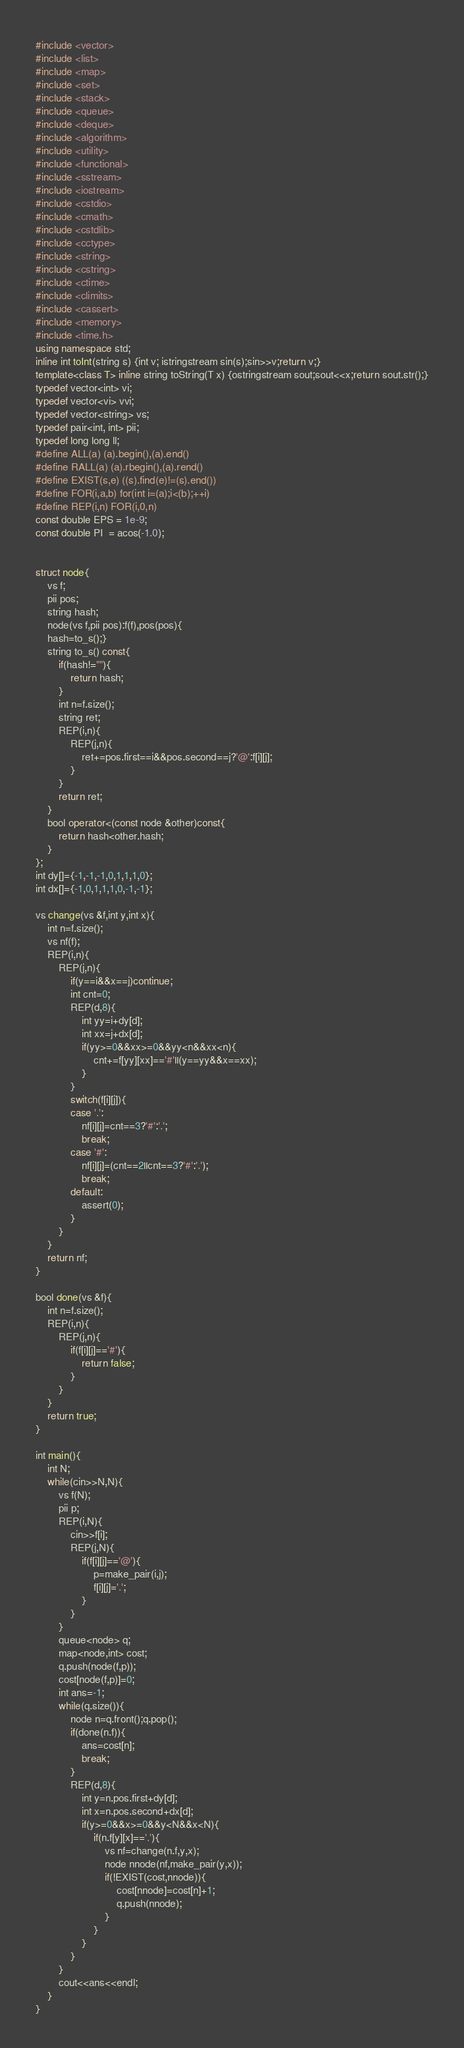Convert code to text. <code><loc_0><loc_0><loc_500><loc_500><_C++_>#include <vector>
#include <list>
#include <map>
#include <set>
#include <stack>
#include <queue>
#include <deque>
#include <algorithm>
#include <utility>
#include <functional>
#include <sstream>
#include <iostream>
#include <cstdio>
#include <cmath>
#include <cstdlib>
#include <cctype>
#include <string>
#include <cstring>
#include <ctime>
#include <climits>
#include <cassert>
#include <memory>
#include <time.h>
using namespace std;
inline int toInt(string s) {int v; istringstream sin(s);sin>>v;return v;}
template<class T> inline string toString(T x) {ostringstream sout;sout<<x;return sout.str();}
typedef vector<int> vi;
typedef vector<vi> vvi;
typedef vector<string> vs;
typedef pair<int, int> pii;
typedef long long ll;
#define ALL(a) (a).begin(),(a).end()
#define RALL(a) (a).rbegin(),(a).rend()
#define EXIST(s,e) ((s).find(e)!=(s).end())
#define FOR(i,a,b) for(int i=(a);i<(b);++i)
#define REP(i,n) FOR(i,0,n)
const double EPS = 1e-9;
const double PI  = acos(-1.0);


struct node{
	vs f;
	pii pos;
	string hash;
	node(vs f,pii pos):f(f),pos(pos){
	hash=to_s();}
	string to_s() const{
		if(hash!=""){
			return hash;
		}
		int n=f.size();
		string ret; 
		REP(i,n){
			REP(j,n){
				ret+=pos.first==i&&pos.second==j?'@':f[i][j];
			}
		}
		return ret;
	}
	bool operator<(const node &other)const{
		return hash<other.hash;
	}
};
int dy[]={-1,-1,-1,0,1,1,1,0};
int dx[]={-1,0,1,1,1,0,-1,-1};

vs change(vs &f,int y,int x){
	int n=f.size();
	vs nf(f);
	REP(i,n){
		REP(j,n){
			if(y==i&&x==j)continue;
			int cnt=0;
			REP(d,8){
				int yy=i+dy[d];
				int xx=j+dx[d];
				if(yy>=0&&xx>=0&&yy<n&&xx<n){
					cnt+=f[yy][xx]=='#'||(y==yy&&x==xx);
				}
			}
			switch(f[i][j]){
			case '.':
				nf[i][j]=cnt==3?'#':'.';
				break;
			case '#':
				nf[i][j]=(cnt==2||cnt==3?'#':'.');
				break;
			default:
				assert(0);
			}
		}
	}
	return nf;
}

bool done(vs &f){
	int n=f.size();
	REP(i,n){
		REP(j,n){
			if(f[i][j]=='#'){
				return false;
			}
		}
	}
	return true;
}

int main(){
	int N;
	while(cin>>N,N){
		vs f(N);
		pii p;
		REP(i,N){
			cin>>f[i];
			REP(j,N){
				if(f[i][j]=='@'){
					p=make_pair(i,j);
					f[i][j]='.';
				}
			}
		}
		queue<node> q;
		map<node,int> cost;
		q.push(node(f,p));
		cost[node(f,p)]=0;
		int ans=-1;
		while(q.size()){
			node n=q.front();q.pop();
			if(done(n.f)){
				ans=cost[n];
				break;
			}
			REP(d,8){
				int y=n.pos.first+dy[d];
				int x=n.pos.second+dx[d];
				if(y>=0&&x>=0&&y<N&&x<N){
					if(n.f[y][x]=='.'){
						vs nf=change(n.f,y,x);
						node nnode(nf,make_pair(y,x));
						if(!EXIST(cost,nnode)){
							cost[nnode]=cost[n]+1;
							q.push(nnode);
						}
					}
				}
			}
		}
		cout<<ans<<endl;
	}
}</code> 